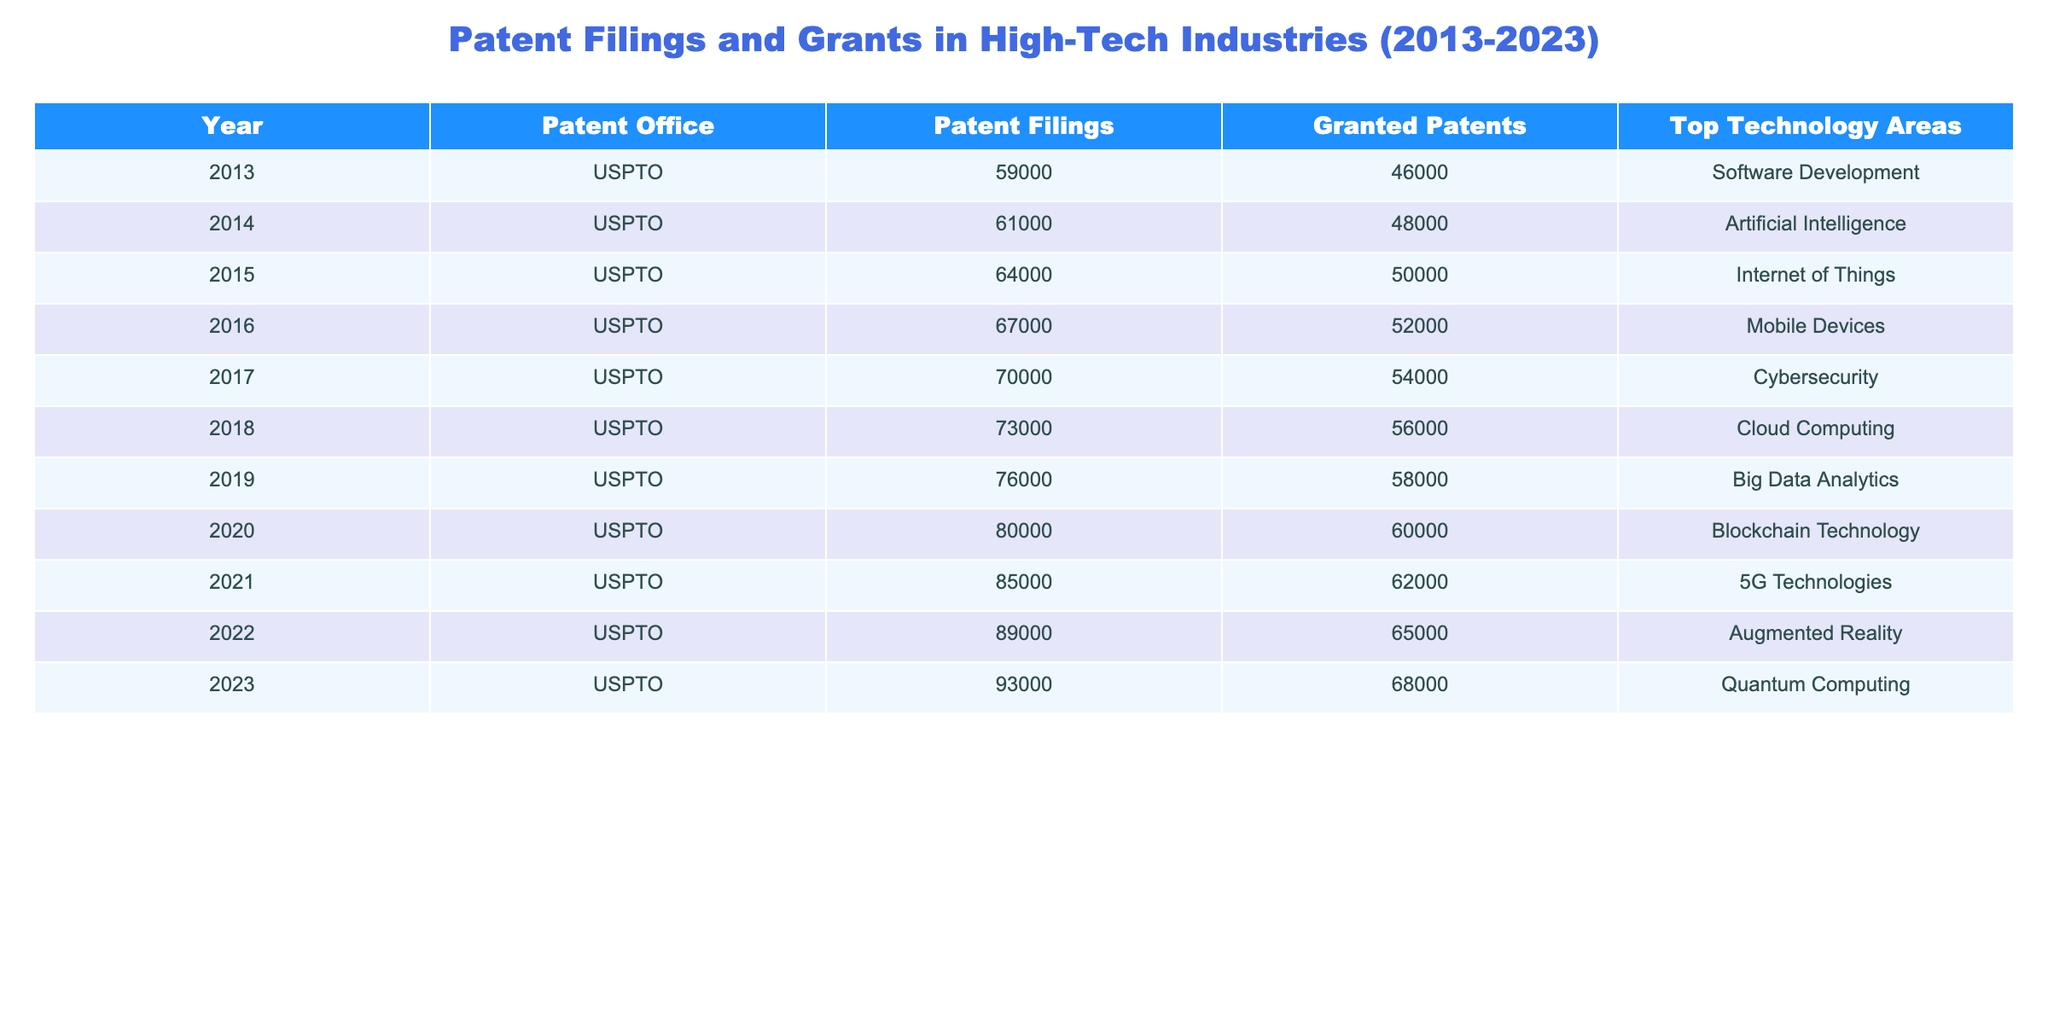What was the total number of patent filings in 2020? The table shows that in 2020, the number of patent filings is listed as 80000.
Answer: 80000 What is the top technology area for patent filings in 2015? Referring to the table, the top technology area for patent filings in 2015 is the Internet of Things.
Answer: Internet of Things In which year did granted patents exceed 55000 for the first time? By examining the granted patents column, 55000 was exceeded starting in 2018, where it reached 56000.
Answer: 2018 What is the average number of granted patents from 2013 to 2023? The granted patents over the years are 46000, 48000, 50000, 52000, 54000, 56000, 58000, 60000, 62000, 65000, and 68000; summing these gives 575000. Dividing by the number of years (11 years), the average is 575000/11 = 52363.64.
Answer: 52363.64 Did the number of patent filings increase every year from 2013 to 2023? By reviewing the table, the number of patent filings consistently increased each year from 59000 in 2013 to 93000 in 2023.
Answer: Yes What is the difference between the number of patent filings in 2022 and 2020? The patent filings in 2022 are 89000 and in 2020 are 80000. The difference is calculated as 89000 - 80000 = 9000.
Answer: 9000 Which year had the highest number of granted patents? The highest number of granted patents is found in 2023 with a total of 68000.
Answer: 2023 How many more patent filings were there in 2023 compared to 2013? In 2023, there were 93000 patent filings, and in 2013, there were 59000. The calculation is 93000 - 59000 = 34000.
Answer: 34000 